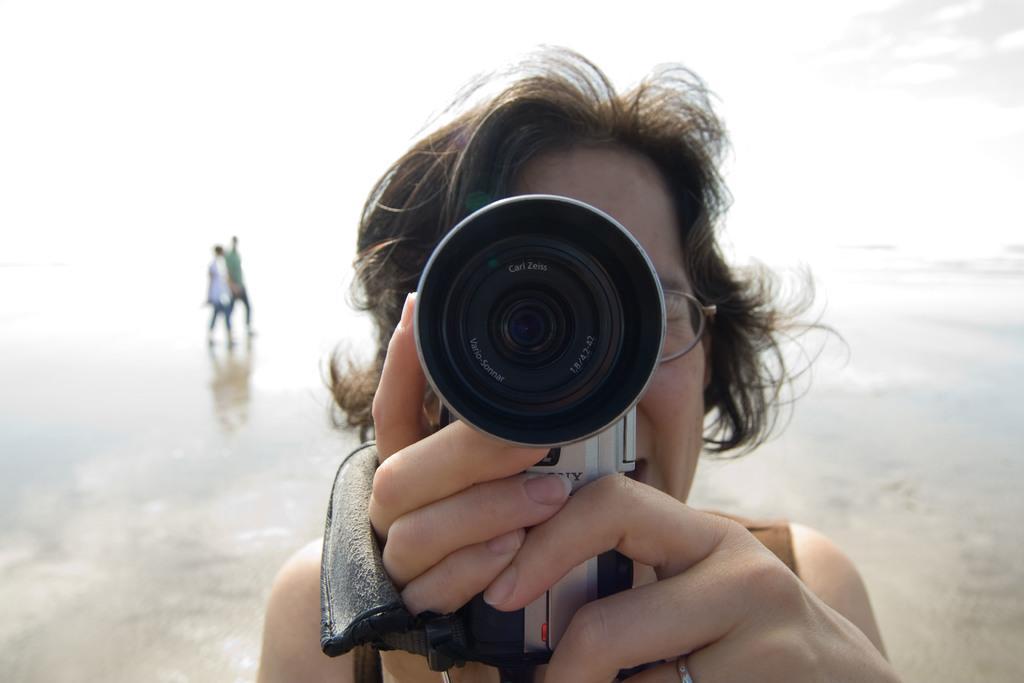Describe this image in one or two sentences. Person in the middle of image is holding a camera. At the back side there are two persons walking. 